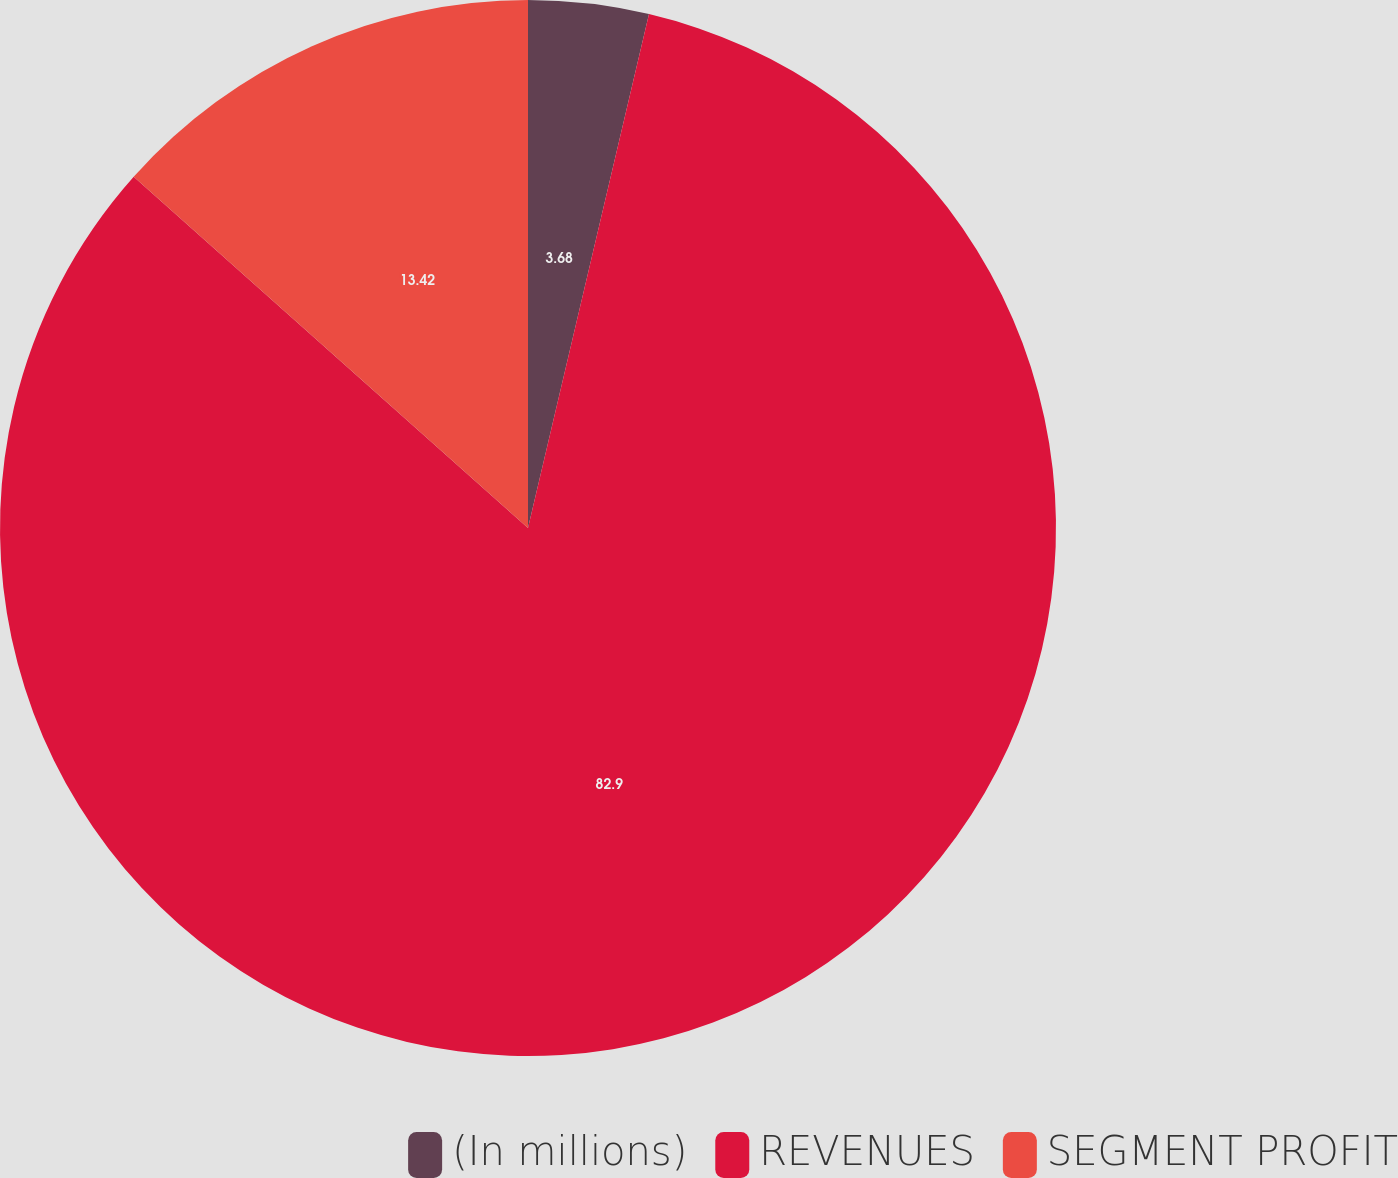<chart> <loc_0><loc_0><loc_500><loc_500><pie_chart><fcel>(In millions)<fcel>REVENUES<fcel>SEGMENT PROFIT<nl><fcel>3.68%<fcel>82.9%<fcel>13.42%<nl></chart> 